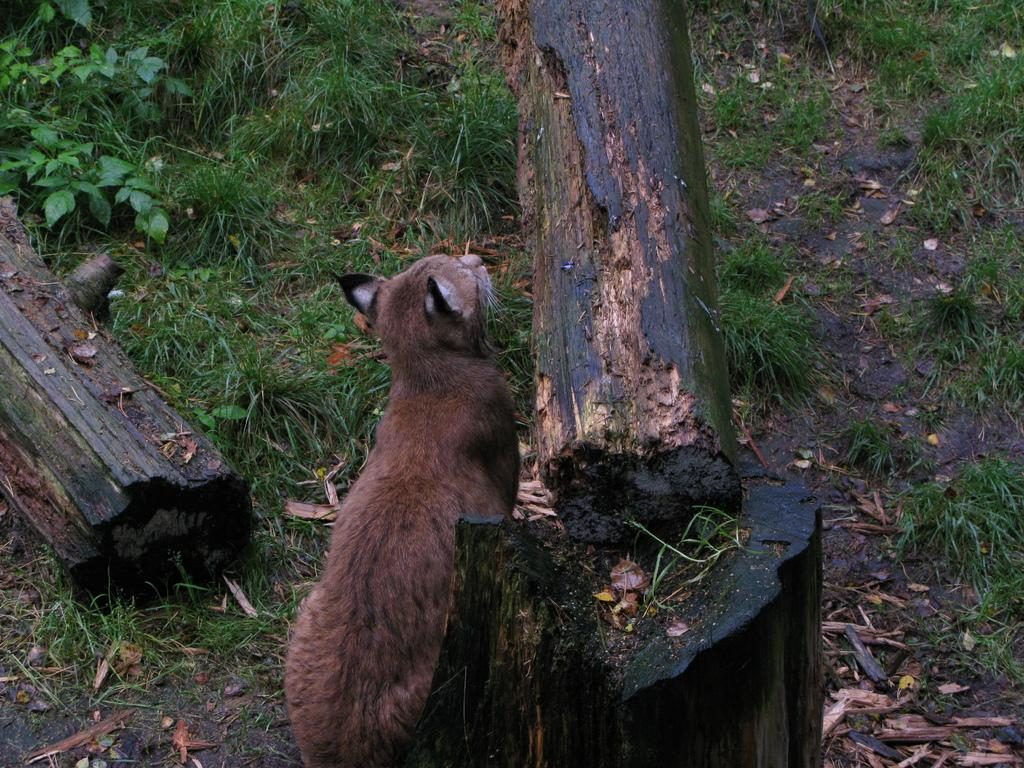What type of creature is in the image? There is an animal in the image. How is the animal positioned in the image? The animal is standing on the ground. What is the surface of the ground covered with? The ground is covered with grass. What other objects can be seen on the ground? There are tree logs on the ground. What type of books can be seen stacked near the animal in the image? There are no books present in the image; it features an animal standing on the grass-covered ground with tree logs nearby. 